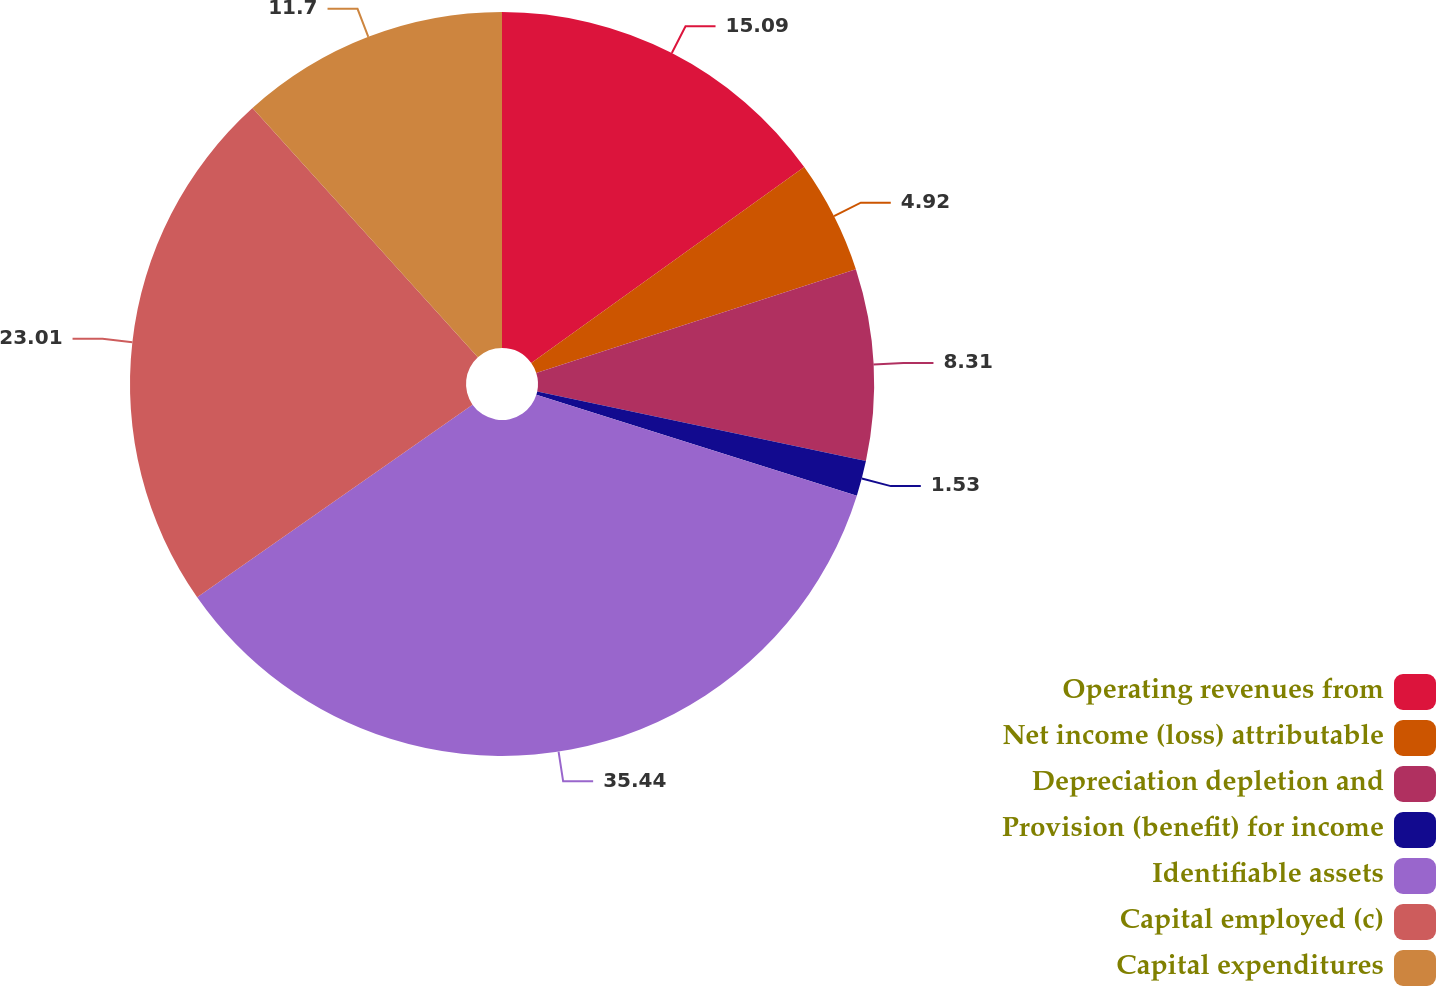Convert chart. <chart><loc_0><loc_0><loc_500><loc_500><pie_chart><fcel>Operating revenues from<fcel>Net income (loss) attributable<fcel>Depreciation depletion and<fcel>Provision (benefit) for income<fcel>Identifiable assets<fcel>Capital employed (c)<fcel>Capital expenditures<nl><fcel>15.09%<fcel>4.92%<fcel>8.31%<fcel>1.53%<fcel>35.43%<fcel>23.01%<fcel>11.7%<nl></chart> 